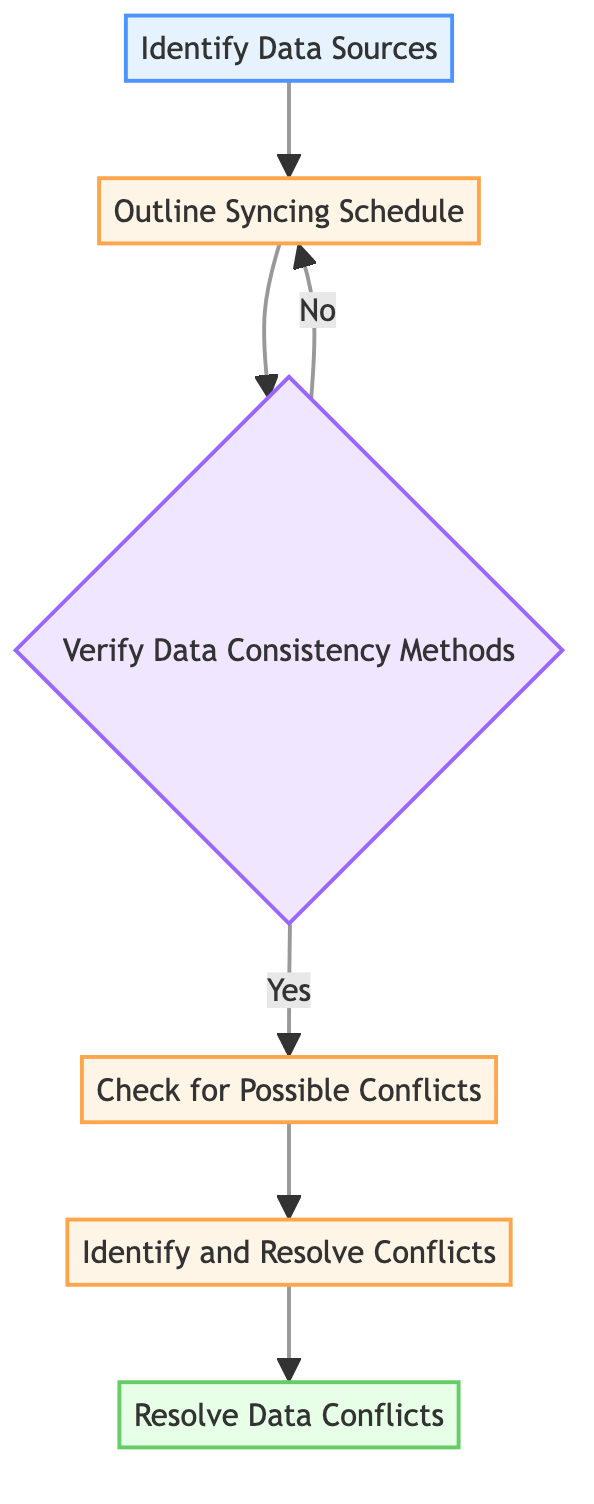What is the first step in the diagram? The first step shown in the diagram is "Identify Data Sources," which is the starting point of the flowchart.
Answer: Identify Data Sources How many total processes are indicated in the flowchart? The flowchart contains four processes: "Outline Syncing Schedule," "Check for Possible Conflicts," "Identify and Resolve Conflicts," and "Resolve Data Conflicts."
Answer: Four What does the decision node ask about? The decision node "Verify Data Consistency Methods" asks whether the methods for ensuring data consistency are reliable or not.
Answer: Are the methods for ensuring data consistency reliable? Which node follows after verifying data consistency if the answer is yes? If the verification of data consistency methods is affirmative (yes), the next node in the flow is "Check for Possible Conflicts."
Answer: Check for Possible Conflicts What happens if the answer to the consistency methods verification is no? If the answer is no, the flowchart indicates that you return to "Outline Syncing Schedule" to reassess the scheduled sync plan.
Answer: Return to Outline Syncing Schedule Explain the relationship between the "Check for Possible Conflicts" and "Identify and Resolve Conflicts." "Check for Possible Conflicts" is a process that leads directly to "Identify and Resolve Conflicts," signifying that after checking for conflicts, one must actively identify and resolve those discrepancies.
Answer: Directly connected What is the final activity in the flowchart? The last activity depicted in the flowchart is "Resolve Data Conflicts," which represents the final step to implement fixes and ensure data integrity.
Answer: Resolve Data Conflicts What are possible reasons to return to the syncing schedule? You would return to the syncing schedule if the methods verifying data consistency are deemed unreliable, implying a need to reassess how syncing is scheduled.
Answer: Unreliable consistency methods How many endpoints are there in the diagram? The flowchart has one endpoint, which is "Resolve Data Conflicts," indicating the final point of the process.
Answer: One 